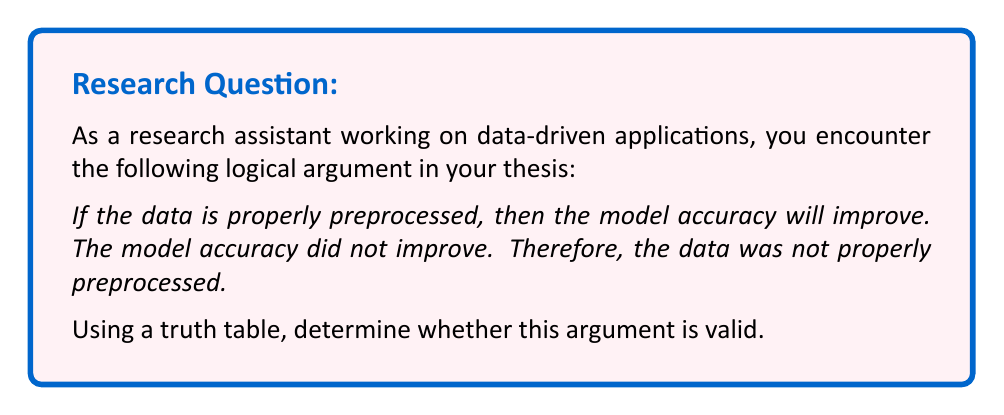Help me with this question. To determine the validity of this logical argument using a truth table, we need to follow these steps:

1. Identify the premises and conclusion:
   Premise 1: If the data is properly preprocessed, then the model accuracy will improve.
   Premise 2: The model accuracy did not improve.
   Conclusion: The data was not properly preprocessed.

2. Assign variables to the statements:
   Let $p$ = "The data is properly preprocessed"
   Let $q$ = "The model accuracy will improve"

3. Translate the argument into symbolic logic:
   Premise 1: $p \rightarrow q$
   Premise 2: $\neg q$
   Conclusion: $\neg p$

4. Construct the truth table:

   $$
   \begin{array}{|c|c|c|c|c|c|}
   \hline
   p & q & p \rightarrow q & \neg q & (p \rightarrow q) \land \neg q & \neg p \\
   \hline
   T & T & T & F & F & F \\
   T & F & F & T & F & F \\
   F & T & T & F & F & T \\
   F & F & T & T & T & T \\
   \hline
   \end{array}
   $$

5. Analyze the truth table:
   - The argument is valid if, in every row where all premises are true, the conclusion is also true.
   - In this case, we need to look at the rows where $(p \rightarrow q) \land \neg q$ is true.
   - We can see that this occurs only in the last row of the truth table.
   - In this row, $\neg p$ is also true.

6. Interpret the results:
   Since the conclusion ($\neg p$) is true in the only row where both premises are true, we can conclude that this argument is valid.

This form of argument is known as Modus Tollens (denying the consequent), which is a valid form of logical reasoning.
Answer: The argument is valid. The truth table shows that when both premises are true (in the last row), the conclusion is also true, satisfying the definition of a valid argument in propositional logic. 